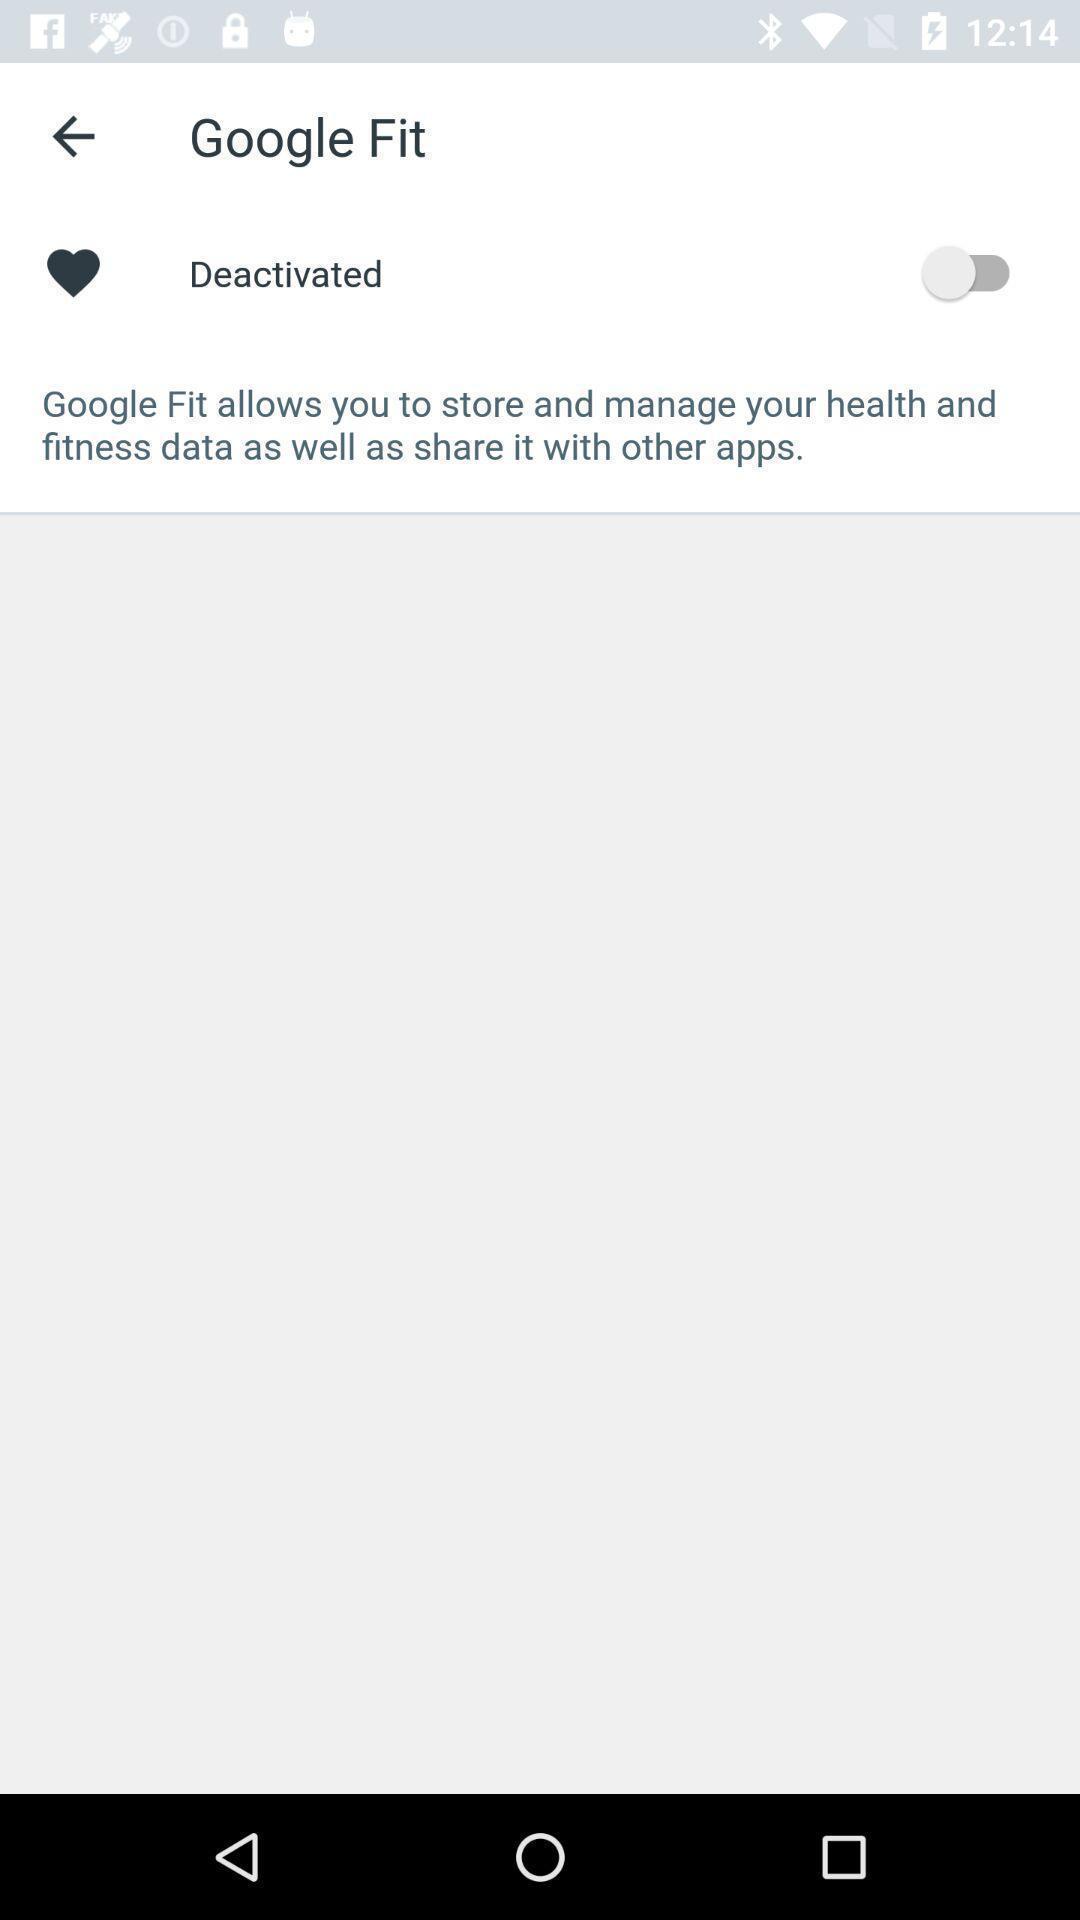What is the overall content of this screenshot? Page with an option in fitness tracking application. 